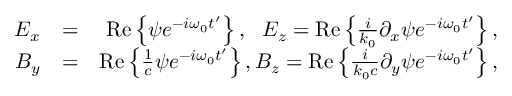Convert formula to latex. <formula><loc_0><loc_0><loc_500><loc_500>\begin{array} { r l r } { E _ { x } } & { = } & { R e \left \{ \psi e ^ { - i \omega _ { 0 } t ^ { \prime } } \right \} , \, E _ { z } = R e \left \{ \frac { i } { k _ { 0 } } \partial _ { x } \psi e ^ { - i \omega _ { 0 } t ^ { \prime } } \right \} , } \\ { B _ { y } } & { = } & { R e \left \{ \frac { 1 } { c } \psi e ^ { - i \omega _ { 0 } t ^ { \prime } } \right \} , B _ { z } = R e \left \{ \frac { i } { k _ { 0 } c } \partial _ { y } \psi e ^ { - i \omega _ { 0 } t ^ { \prime } } \right \} , } \end{array}</formula> 